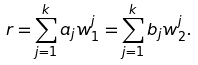<formula> <loc_0><loc_0><loc_500><loc_500>r = \sum _ { j = 1 } ^ { k } a _ { j } w _ { 1 } ^ { j } = \sum _ { j = 1 } ^ { k } b _ { j } w ^ { j } _ { 2 } .</formula> 